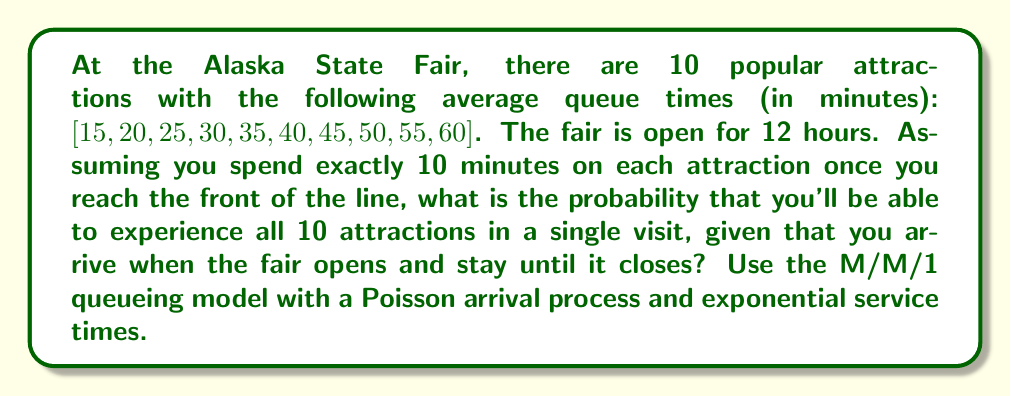Solve this math problem. Let's approach this step-by-step:

1) First, we need to calculate the total time available:
   12 hours = 720 minutes

2) Now, let's calculate the total time needed for all attractions:
   $$T_{total} = \sum_{i=1}^{10} (Q_i + 10)$$
   Where $Q_i$ is the queue time for attraction $i$.

   $$T_{total} = (15+10) + (20+10) + ... + (60+10) = 485 minutes$$

3) The remaining time for queueing variability is:
   $$T_{remaining} = 720 - 485 = 235 minutes$$

4) In queueing theory, the M/M/1 model assumes exponential service times. The probability of completing service within time $t$ is given by:
   $$P(T \leq t) = 1 - e^{-\mu t}$$
   where $\mu$ is the service rate.

5) For each attraction, we can calculate $\mu_i = \frac{1}{Q_i}$

6) The probability of experiencing all attractions within the time limit is the product of the individual probabilities:

   $$P_{all} = \prod_{i=1}^{10} (1 - e^{-\mu_i \cdot 235})$$

7) Calculating each probability:
   $$P_1 = 1 - e^{-\frac{1}{15} \cdot 235} = 0.9999$$
   $$P_2 = 1 - e^{-\frac{1}{20} \cdot 235} = 0.9997$$
   $$...$$
   $$P_{10} = 1 - e^{-\frac{1}{60} \cdot 235} = 0.9801$$

8) Multiplying all probabilities:
   $$P_{all} = 0.9999 \cdot 0.9997 \cdot ... \cdot 0.9801 = 0.9789$$

Therefore, the probability of experiencing all 10 attractions in a single visit is approximately 0.9789 or 97.89%.
Answer: 0.9789 